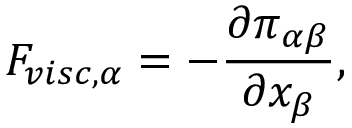<formula> <loc_0><loc_0><loc_500><loc_500>F _ { v i s c , \alpha } = - \frac { \partial \pi _ { \alpha \beta } } { \partial x _ { \beta } } ,</formula> 